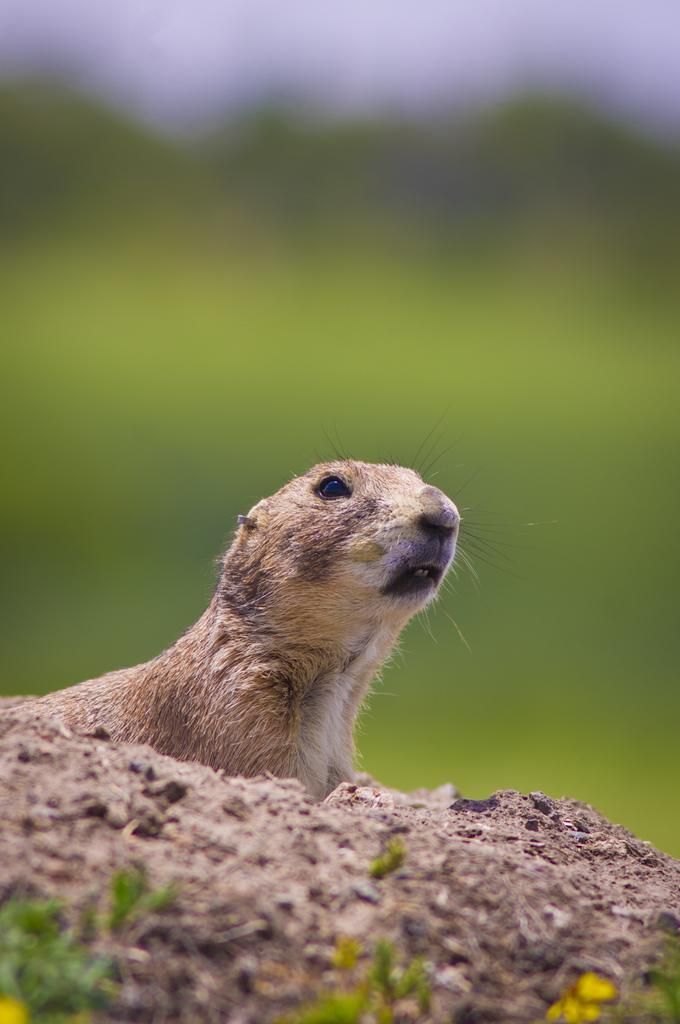What is located at the bottom of the picture? There are plants at the bottom of the picture. What type of living creature can be seen in the image? There is an animal visible in the image. How would you describe the background of the image? The background of the image is blurry. How many ants can be seen carrying a vase in the image? There are no ants or vases present in the image. Can you describe the animal's ability to stretch in the image? There is no indication of the animal stretching in the image. 